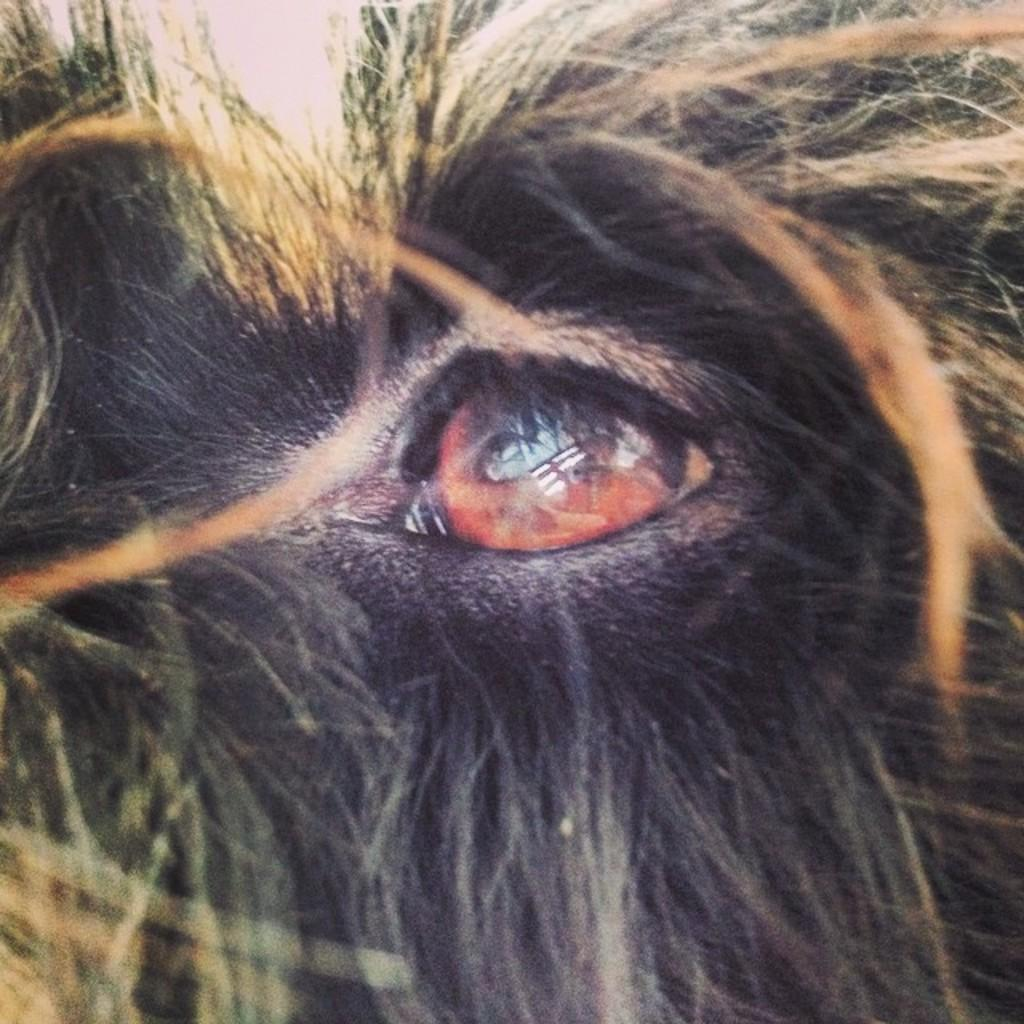What is the main subject in the foreground of the image? There is an animal's eye in the foreground of the image. Can you describe the texture around the animal's eye? Fur is visible around the animal's eye. What type of force is being applied to the sofa in the image? There is no sofa present in the image, so it is not possible to determine if any force is being applied to it. 